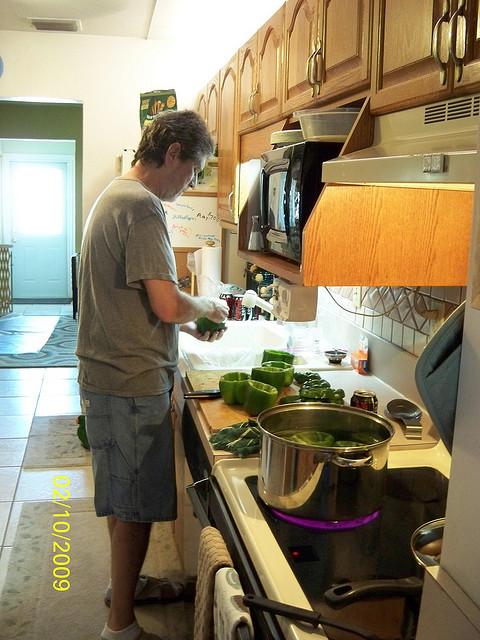How many people can be seen in the kitchen?
Answer briefly. 1. Is this an airport?
Give a very brief answer. No. What green vegetables are being prepared?
Be succinct. Peppers. What color is the burner on the stove?
Give a very brief answer. Purple. Are the cook's utensils in motion?
Write a very short answer. No. How many people are in the kitchen?
Answer briefly. 1. Is the man preparing dinner?
Quick response, please. Yes. 